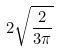Convert formula to latex. <formula><loc_0><loc_0><loc_500><loc_500>2 \sqrt { \frac { 2 } { 3 \pi } }</formula> 